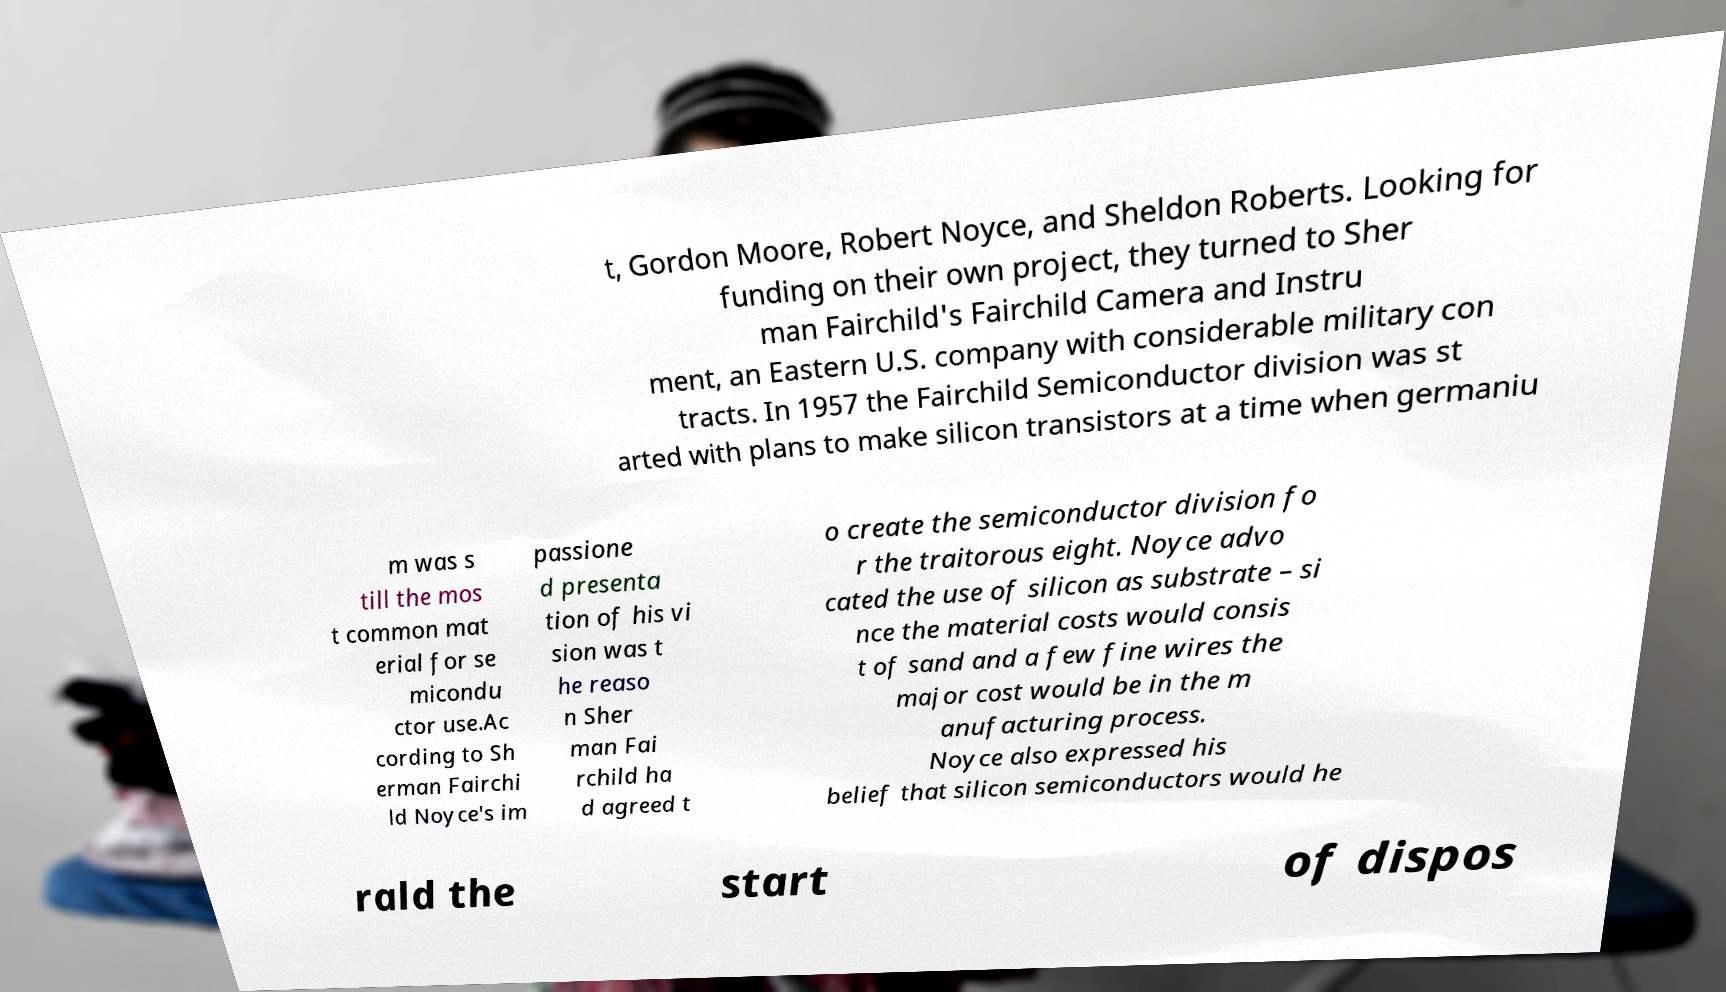For documentation purposes, I need the text within this image transcribed. Could you provide that? t, Gordon Moore, Robert Noyce, and Sheldon Roberts. Looking for funding on their own project, they turned to Sher man Fairchild's Fairchild Camera and Instru ment, an Eastern U.S. company with considerable military con tracts. In 1957 the Fairchild Semiconductor division was st arted with plans to make silicon transistors at a time when germaniu m was s till the mos t common mat erial for se micondu ctor use.Ac cording to Sh erman Fairchi ld Noyce's im passione d presenta tion of his vi sion was t he reaso n Sher man Fai rchild ha d agreed t o create the semiconductor division fo r the traitorous eight. Noyce advo cated the use of silicon as substrate – si nce the material costs would consis t of sand and a few fine wires the major cost would be in the m anufacturing process. Noyce also expressed his belief that silicon semiconductors would he rald the start of dispos 